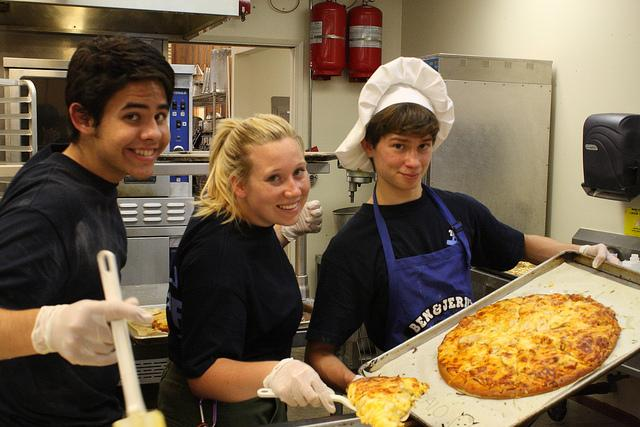How are the three people feeling in the kitchen? proud 